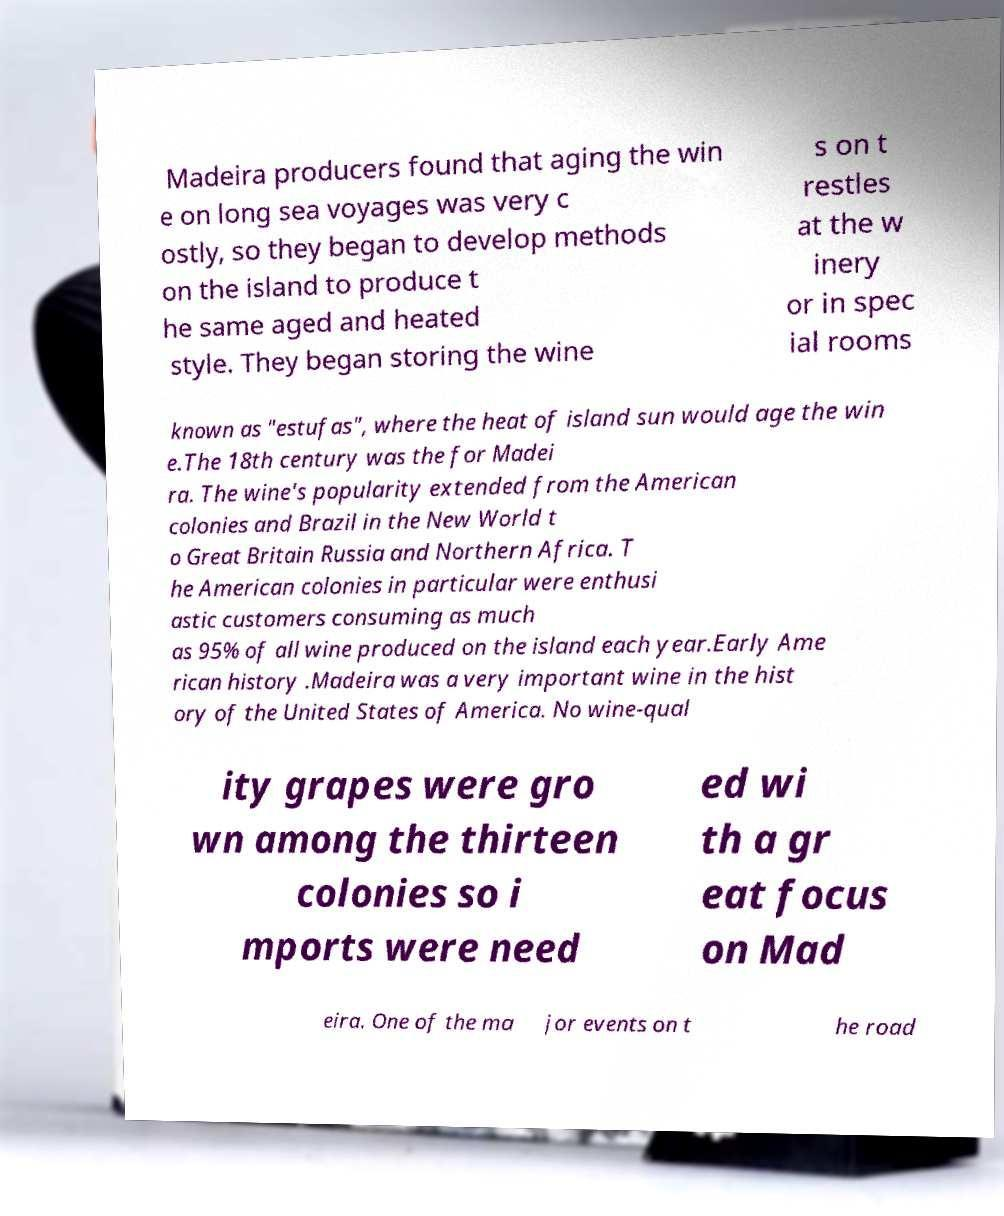Please read and relay the text visible in this image. What does it say? Madeira producers found that aging the win e on long sea voyages was very c ostly, so they began to develop methods on the island to produce t he same aged and heated style. They began storing the wine s on t restles at the w inery or in spec ial rooms known as "estufas", where the heat of island sun would age the win e.The 18th century was the for Madei ra. The wine's popularity extended from the American colonies and Brazil in the New World t o Great Britain Russia and Northern Africa. T he American colonies in particular were enthusi astic customers consuming as much as 95% of all wine produced on the island each year.Early Ame rican history .Madeira was a very important wine in the hist ory of the United States of America. No wine-qual ity grapes were gro wn among the thirteen colonies so i mports were need ed wi th a gr eat focus on Mad eira. One of the ma jor events on t he road 